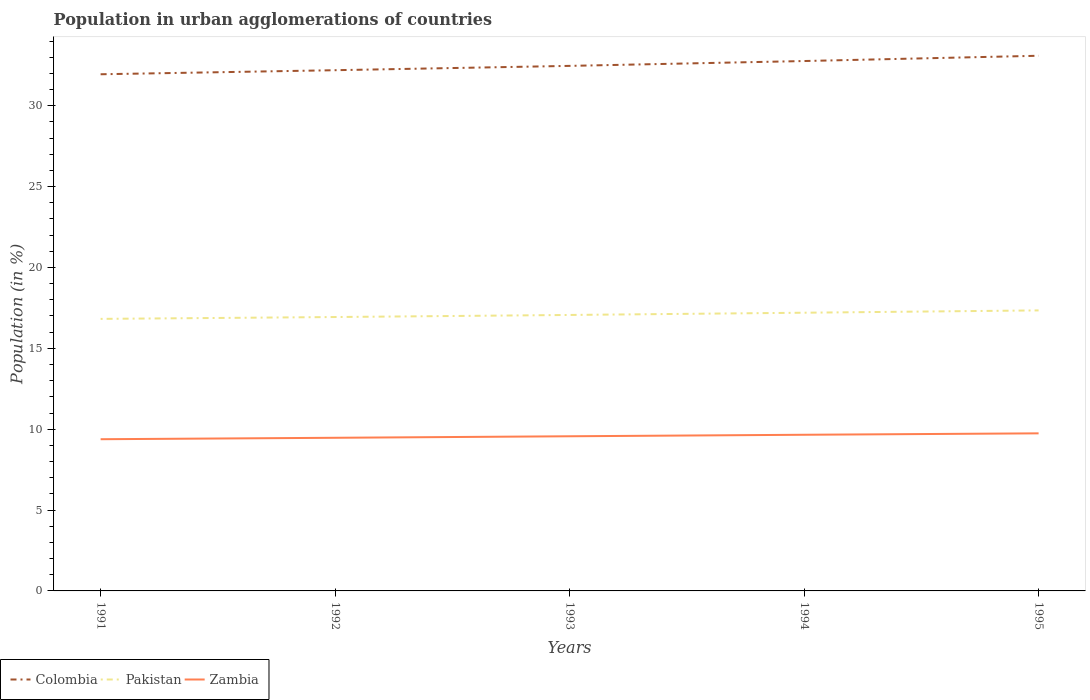Is the number of lines equal to the number of legend labels?
Provide a short and direct response. Yes. Across all years, what is the maximum percentage of population in urban agglomerations in Colombia?
Keep it short and to the point. 31.95. What is the total percentage of population in urban agglomerations in Colombia in the graph?
Ensure brevity in your answer.  -0.89. What is the difference between the highest and the second highest percentage of population in urban agglomerations in Colombia?
Provide a short and direct response. 1.14. Is the percentage of population in urban agglomerations in Zambia strictly greater than the percentage of population in urban agglomerations in Pakistan over the years?
Your response must be concise. Yes. Does the graph contain grids?
Your answer should be compact. No. What is the title of the graph?
Offer a terse response. Population in urban agglomerations of countries. What is the label or title of the X-axis?
Ensure brevity in your answer.  Years. What is the Population (in %) in Colombia in 1991?
Your answer should be compact. 31.95. What is the Population (in %) in Pakistan in 1991?
Ensure brevity in your answer.  16.82. What is the Population (in %) in Zambia in 1991?
Your answer should be compact. 9.38. What is the Population (in %) in Colombia in 1992?
Provide a short and direct response. 32.2. What is the Population (in %) of Pakistan in 1992?
Keep it short and to the point. 16.94. What is the Population (in %) in Zambia in 1992?
Ensure brevity in your answer.  9.47. What is the Population (in %) in Colombia in 1993?
Your response must be concise. 32.46. What is the Population (in %) of Pakistan in 1993?
Ensure brevity in your answer.  17.06. What is the Population (in %) of Zambia in 1993?
Ensure brevity in your answer.  9.56. What is the Population (in %) of Colombia in 1994?
Keep it short and to the point. 32.76. What is the Population (in %) in Pakistan in 1994?
Provide a short and direct response. 17.2. What is the Population (in %) in Zambia in 1994?
Your answer should be compact. 9.66. What is the Population (in %) of Colombia in 1995?
Your answer should be compact. 33.09. What is the Population (in %) in Pakistan in 1995?
Your answer should be compact. 17.35. What is the Population (in %) of Zambia in 1995?
Keep it short and to the point. 9.74. Across all years, what is the maximum Population (in %) of Colombia?
Your response must be concise. 33.09. Across all years, what is the maximum Population (in %) of Pakistan?
Make the answer very short. 17.35. Across all years, what is the maximum Population (in %) in Zambia?
Offer a terse response. 9.74. Across all years, what is the minimum Population (in %) in Colombia?
Your response must be concise. 31.95. Across all years, what is the minimum Population (in %) in Pakistan?
Ensure brevity in your answer.  16.82. Across all years, what is the minimum Population (in %) in Zambia?
Your response must be concise. 9.38. What is the total Population (in %) in Colombia in the graph?
Offer a very short reply. 162.46. What is the total Population (in %) in Pakistan in the graph?
Your response must be concise. 85.37. What is the total Population (in %) of Zambia in the graph?
Your answer should be very brief. 47.81. What is the difference between the Population (in %) in Colombia in 1991 and that in 1992?
Offer a terse response. -0.25. What is the difference between the Population (in %) of Pakistan in 1991 and that in 1992?
Your answer should be compact. -0.11. What is the difference between the Population (in %) in Zambia in 1991 and that in 1992?
Your response must be concise. -0.09. What is the difference between the Population (in %) in Colombia in 1991 and that in 1993?
Make the answer very short. -0.52. What is the difference between the Population (in %) of Pakistan in 1991 and that in 1993?
Provide a short and direct response. -0.24. What is the difference between the Population (in %) of Zambia in 1991 and that in 1993?
Your response must be concise. -0.18. What is the difference between the Population (in %) of Colombia in 1991 and that in 1994?
Ensure brevity in your answer.  -0.82. What is the difference between the Population (in %) of Pakistan in 1991 and that in 1994?
Offer a terse response. -0.38. What is the difference between the Population (in %) of Zambia in 1991 and that in 1994?
Provide a succinct answer. -0.28. What is the difference between the Population (in %) of Colombia in 1991 and that in 1995?
Provide a short and direct response. -1.14. What is the difference between the Population (in %) of Pakistan in 1991 and that in 1995?
Make the answer very short. -0.52. What is the difference between the Population (in %) in Zambia in 1991 and that in 1995?
Offer a terse response. -0.36. What is the difference between the Population (in %) in Colombia in 1992 and that in 1993?
Offer a terse response. -0.27. What is the difference between the Population (in %) of Pakistan in 1992 and that in 1993?
Your answer should be compact. -0.13. What is the difference between the Population (in %) in Zambia in 1992 and that in 1993?
Keep it short and to the point. -0.09. What is the difference between the Population (in %) of Colombia in 1992 and that in 1994?
Offer a very short reply. -0.57. What is the difference between the Population (in %) of Pakistan in 1992 and that in 1994?
Make the answer very short. -0.27. What is the difference between the Population (in %) of Zambia in 1992 and that in 1994?
Your answer should be compact. -0.19. What is the difference between the Population (in %) of Colombia in 1992 and that in 1995?
Your answer should be compact. -0.89. What is the difference between the Population (in %) in Pakistan in 1992 and that in 1995?
Provide a short and direct response. -0.41. What is the difference between the Population (in %) of Zambia in 1992 and that in 1995?
Your response must be concise. -0.27. What is the difference between the Population (in %) of Colombia in 1993 and that in 1994?
Give a very brief answer. -0.3. What is the difference between the Population (in %) in Pakistan in 1993 and that in 1994?
Give a very brief answer. -0.14. What is the difference between the Population (in %) in Zambia in 1993 and that in 1994?
Offer a terse response. -0.09. What is the difference between the Population (in %) in Colombia in 1993 and that in 1995?
Provide a short and direct response. -0.63. What is the difference between the Population (in %) in Pakistan in 1993 and that in 1995?
Give a very brief answer. -0.28. What is the difference between the Population (in %) in Zambia in 1993 and that in 1995?
Your answer should be very brief. -0.18. What is the difference between the Population (in %) in Colombia in 1994 and that in 1995?
Keep it short and to the point. -0.33. What is the difference between the Population (in %) of Pakistan in 1994 and that in 1995?
Your answer should be compact. -0.14. What is the difference between the Population (in %) in Zambia in 1994 and that in 1995?
Ensure brevity in your answer.  -0.09. What is the difference between the Population (in %) in Colombia in 1991 and the Population (in %) in Pakistan in 1992?
Your response must be concise. 15.01. What is the difference between the Population (in %) of Colombia in 1991 and the Population (in %) of Zambia in 1992?
Your answer should be compact. 22.48. What is the difference between the Population (in %) in Pakistan in 1991 and the Population (in %) in Zambia in 1992?
Your answer should be compact. 7.35. What is the difference between the Population (in %) in Colombia in 1991 and the Population (in %) in Pakistan in 1993?
Your answer should be very brief. 14.88. What is the difference between the Population (in %) in Colombia in 1991 and the Population (in %) in Zambia in 1993?
Ensure brevity in your answer.  22.38. What is the difference between the Population (in %) of Pakistan in 1991 and the Population (in %) of Zambia in 1993?
Your answer should be compact. 7.26. What is the difference between the Population (in %) in Colombia in 1991 and the Population (in %) in Pakistan in 1994?
Your answer should be very brief. 14.74. What is the difference between the Population (in %) of Colombia in 1991 and the Population (in %) of Zambia in 1994?
Provide a short and direct response. 22.29. What is the difference between the Population (in %) in Pakistan in 1991 and the Population (in %) in Zambia in 1994?
Your answer should be compact. 7.17. What is the difference between the Population (in %) of Colombia in 1991 and the Population (in %) of Pakistan in 1995?
Offer a terse response. 14.6. What is the difference between the Population (in %) in Colombia in 1991 and the Population (in %) in Zambia in 1995?
Ensure brevity in your answer.  22.2. What is the difference between the Population (in %) of Pakistan in 1991 and the Population (in %) of Zambia in 1995?
Ensure brevity in your answer.  7.08. What is the difference between the Population (in %) of Colombia in 1992 and the Population (in %) of Pakistan in 1993?
Provide a succinct answer. 15.13. What is the difference between the Population (in %) in Colombia in 1992 and the Population (in %) in Zambia in 1993?
Give a very brief answer. 22.63. What is the difference between the Population (in %) in Pakistan in 1992 and the Population (in %) in Zambia in 1993?
Offer a very short reply. 7.37. What is the difference between the Population (in %) in Colombia in 1992 and the Population (in %) in Pakistan in 1994?
Keep it short and to the point. 15. What is the difference between the Population (in %) of Colombia in 1992 and the Population (in %) of Zambia in 1994?
Make the answer very short. 22.54. What is the difference between the Population (in %) in Pakistan in 1992 and the Population (in %) in Zambia in 1994?
Make the answer very short. 7.28. What is the difference between the Population (in %) in Colombia in 1992 and the Population (in %) in Pakistan in 1995?
Provide a succinct answer. 14.85. What is the difference between the Population (in %) in Colombia in 1992 and the Population (in %) in Zambia in 1995?
Offer a terse response. 22.45. What is the difference between the Population (in %) in Pakistan in 1992 and the Population (in %) in Zambia in 1995?
Offer a very short reply. 7.19. What is the difference between the Population (in %) of Colombia in 1993 and the Population (in %) of Pakistan in 1994?
Offer a terse response. 15.26. What is the difference between the Population (in %) of Colombia in 1993 and the Population (in %) of Zambia in 1994?
Keep it short and to the point. 22.81. What is the difference between the Population (in %) of Pakistan in 1993 and the Population (in %) of Zambia in 1994?
Offer a terse response. 7.41. What is the difference between the Population (in %) of Colombia in 1993 and the Population (in %) of Pakistan in 1995?
Your answer should be compact. 15.12. What is the difference between the Population (in %) in Colombia in 1993 and the Population (in %) in Zambia in 1995?
Ensure brevity in your answer.  22.72. What is the difference between the Population (in %) in Pakistan in 1993 and the Population (in %) in Zambia in 1995?
Provide a short and direct response. 7.32. What is the difference between the Population (in %) in Colombia in 1994 and the Population (in %) in Pakistan in 1995?
Offer a very short reply. 15.42. What is the difference between the Population (in %) of Colombia in 1994 and the Population (in %) of Zambia in 1995?
Offer a very short reply. 23.02. What is the difference between the Population (in %) in Pakistan in 1994 and the Population (in %) in Zambia in 1995?
Provide a short and direct response. 7.46. What is the average Population (in %) of Colombia per year?
Your response must be concise. 32.49. What is the average Population (in %) of Pakistan per year?
Keep it short and to the point. 17.07. What is the average Population (in %) in Zambia per year?
Provide a succinct answer. 9.56. In the year 1991, what is the difference between the Population (in %) of Colombia and Population (in %) of Pakistan?
Provide a short and direct response. 15.12. In the year 1991, what is the difference between the Population (in %) of Colombia and Population (in %) of Zambia?
Your response must be concise. 22.57. In the year 1991, what is the difference between the Population (in %) of Pakistan and Population (in %) of Zambia?
Give a very brief answer. 7.44. In the year 1992, what is the difference between the Population (in %) in Colombia and Population (in %) in Pakistan?
Your answer should be very brief. 15.26. In the year 1992, what is the difference between the Population (in %) in Colombia and Population (in %) in Zambia?
Your response must be concise. 22.73. In the year 1992, what is the difference between the Population (in %) in Pakistan and Population (in %) in Zambia?
Ensure brevity in your answer.  7.47. In the year 1993, what is the difference between the Population (in %) of Colombia and Population (in %) of Pakistan?
Give a very brief answer. 15.4. In the year 1993, what is the difference between the Population (in %) of Colombia and Population (in %) of Zambia?
Your answer should be compact. 22.9. In the year 1993, what is the difference between the Population (in %) in Pakistan and Population (in %) in Zambia?
Make the answer very short. 7.5. In the year 1994, what is the difference between the Population (in %) in Colombia and Population (in %) in Pakistan?
Ensure brevity in your answer.  15.56. In the year 1994, what is the difference between the Population (in %) in Colombia and Population (in %) in Zambia?
Keep it short and to the point. 23.11. In the year 1994, what is the difference between the Population (in %) in Pakistan and Population (in %) in Zambia?
Give a very brief answer. 7.55. In the year 1995, what is the difference between the Population (in %) of Colombia and Population (in %) of Pakistan?
Your response must be concise. 15.75. In the year 1995, what is the difference between the Population (in %) of Colombia and Population (in %) of Zambia?
Your answer should be very brief. 23.35. In the year 1995, what is the difference between the Population (in %) in Pakistan and Population (in %) in Zambia?
Ensure brevity in your answer.  7.6. What is the ratio of the Population (in %) in Pakistan in 1991 to that in 1992?
Your answer should be compact. 0.99. What is the ratio of the Population (in %) in Zambia in 1991 to that in 1992?
Offer a very short reply. 0.99. What is the ratio of the Population (in %) of Colombia in 1991 to that in 1993?
Provide a short and direct response. 0.98. What is the ratio of the Population (in %) of Pakistan in 1991 to that in 1993?
Make the answer very short. 0.99. What is the ratio of the Population (in %) in Zambia in 1991 to that in 1993?
Ensure brevity in your answer.  0.98. What is the ratio of the Population (in %) in Colombia in 1991 to that in 1994?
Make the answer very short. 0.97. What is the ratio of the Population (in %) in Pakistan in 1991 to that in 1994?
Your response must be concise. 0.98. What is the ratio of the Population (in %) in Zambia in 1991 to that in 1994?
Keep it short and to the point. 0.97. What is the ratio of the Population (in %) of Colombia in 1991 to that in 1995?
Your answer should be very brief. 0.97. What is the ratio of the Population (in %) in Pakistan in 1991 to that in 1995?
Provide a short and direct response. 0.97. What is the ratio of the Population (in %) of Zambia in 1991 to that in 1995?
Offer a terse response. 0.96. What is the ratio of the Population (in %) in Colombia in 1992 to that in 1993?
Offer a terse response. 0.99. What is the ratio of the Population (in %) of Zambia in 1992 to that in 1993?
Offer a terse response. 0.99. What is the ratio of the Population (in %) of Colombia in 1992 to that in 1994?
Give a very brief answer. 0.98. What is the ratio of the Population (in %) in Pakistan in 1992 to that in 1994?
Provide a succinct answer. 0.98. What is the ratio of the Population (in %) of Zambia in 1992 to that in 1994?
Your response must be concise. 0.98. What is the ratio of the Population (in %) in Pakistan in 1992 to that in 1995?
Your answer should be very brief. 0.98. What is the ratio of the Population (in %) of Zambia in 1992 to that in 1995?
Provide a succinct answer. 0.97. What is the ratio of the Population (in %) of Colombia in 1993 to that in 1994?
Offer a very short reply. 0.99. What is the ratio of the Population (in %) of Pakistan in 1993 to that in 1994?
Offer a terse response. 0.99. What is the ratio of the Population (in %) of Colombia in 1993 to that in 1995?
Your answer should be compact. 0.98. What is the ratio of the Population (in %) of Pakistan in 1993 to that in 1995?
Provide a short and direct response. 0.98. What is the ratio of the Population (in %) in Zambia in 1993 to that in 1995?
Your answer should be compact. 0.98. What is the ratio of the Population (in %) of Colombia in 1994 to that in 1995?
Provide a short and direct response. 0.99. What is the ratio of the Population (in %) in Pakistan in 1994 to that in 1995?
Your response must be concise. 0.99. What is the ratio of the Population (in %) in Zambia in 1994 to that in 1995?
Your response must be concise. 0.99. What is the difference between the highest and the second highest Population (in %) of Colombia?
Provide a short and direct response. 0.33. What is the difference between the highest and the second highest Population (in %) of Pakistan?
Ensure brevity in your answer.  0.14. What is the difference between the highest and the second highest Population (in %) of Zambia?
Ensure brevity in your answer.  0.09. What is the difference between the highest and the lowest Population (in %) of Colombia?
Offer a terse response. 1.14. What is the difference between the highest and the lowest Population (in %) in Pakistan?
Make the answer very short. 0.52. What is the difference between the highest and the lowest Population (in %) of Zambia?
Give a very brief answer. 0.36. 